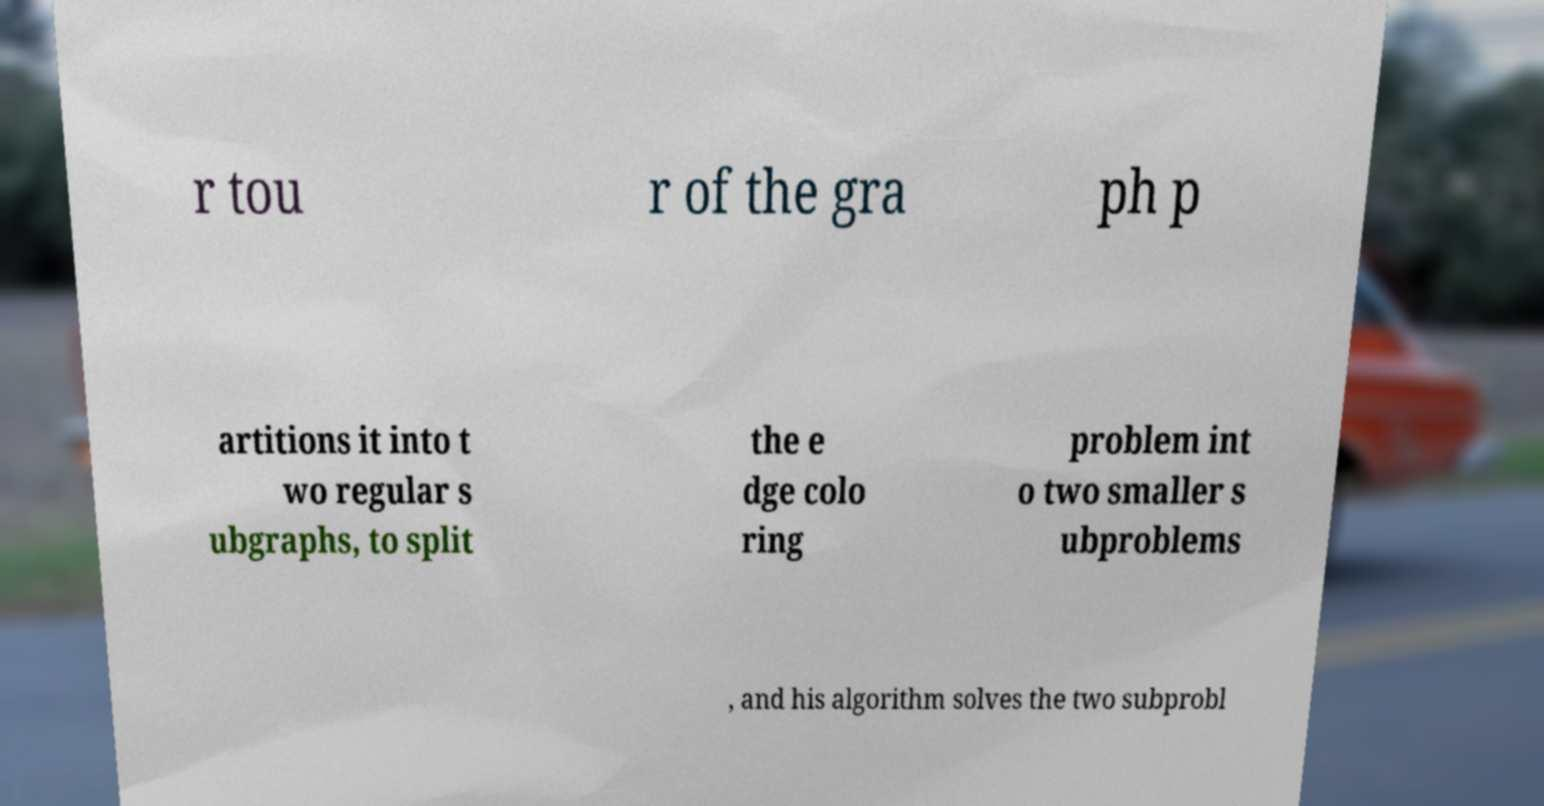I need the written content from this picture converted into text. Can you do that? r tou r of the gra ph p artitions it into t wo regular s ubgraphs, to split the e dge colo ring problem int o two smaller s ubproblems , and his algorithm solves the two subprobl 